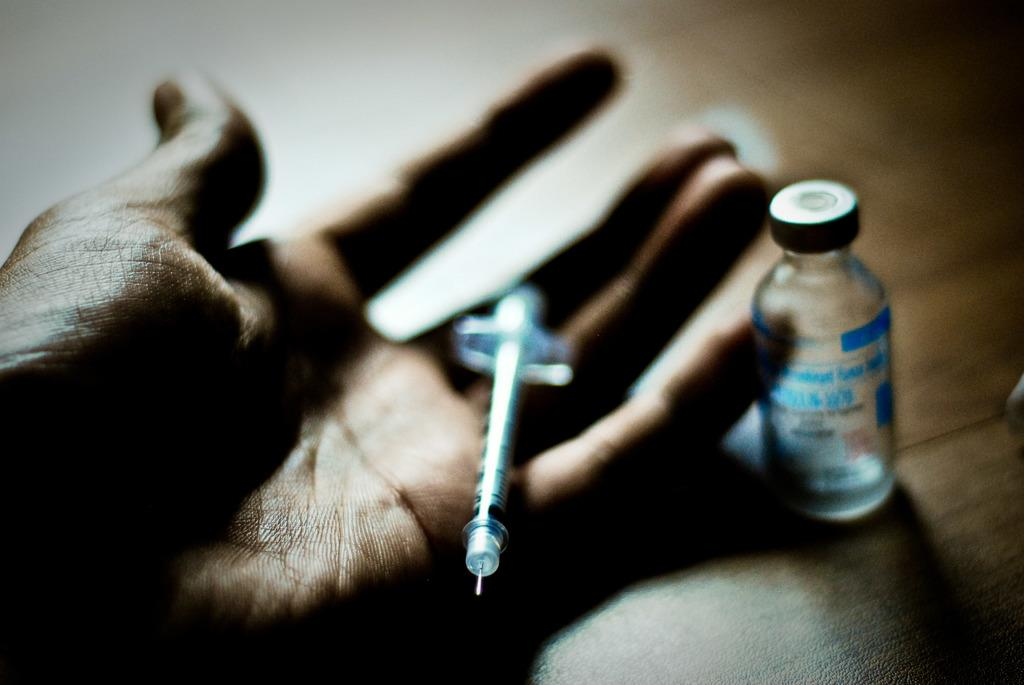What is happening to the hand in the image? There is an injection in a hand in the image. What else can be seen in the image besides the hand? There is a bottle in the image. What type of curtain is hanging in the background of the image? There is no curtain present in the image; it only features a hand with an injection and a bottle. 